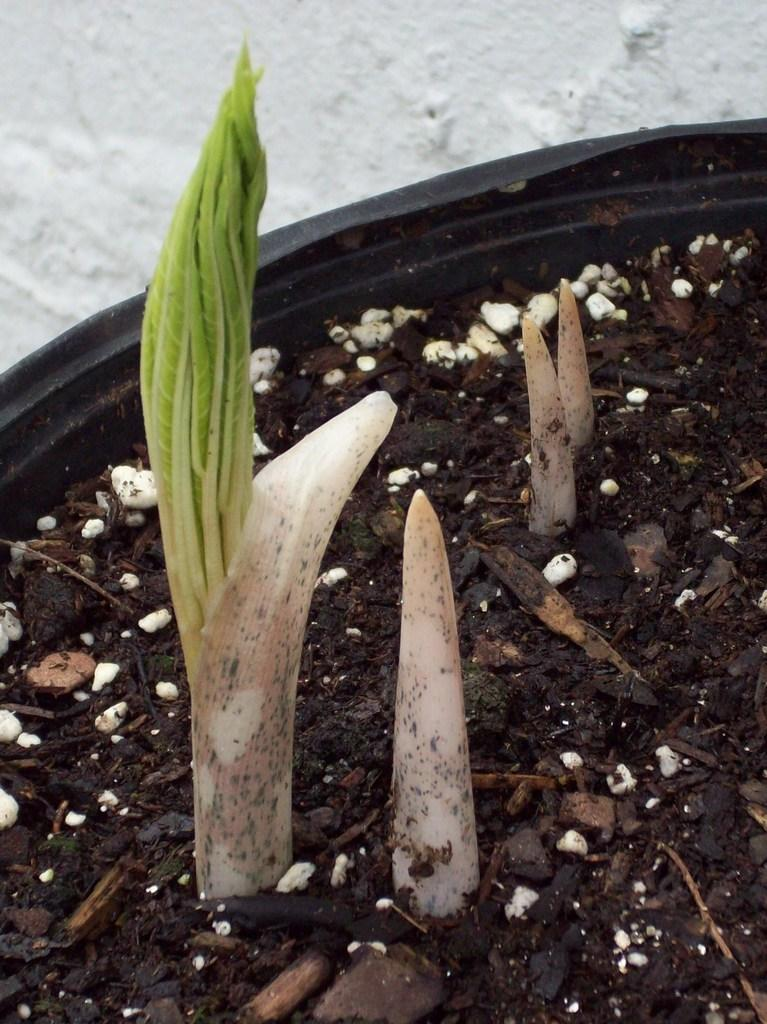What type of plant can be seen in the image? There is a houseplant in the image. What can be seen in the background of the image? The ground is visible in the background of the image. What type of oil is being used to maintain the houseplant in the image? There is no mention of oil or any maintenance activity related to the houseplant in the image. 